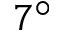Convert formula to latex. <formula><loc_0><loc_0><loc_500><loc_500>7 ^ { \circ }</formula> 